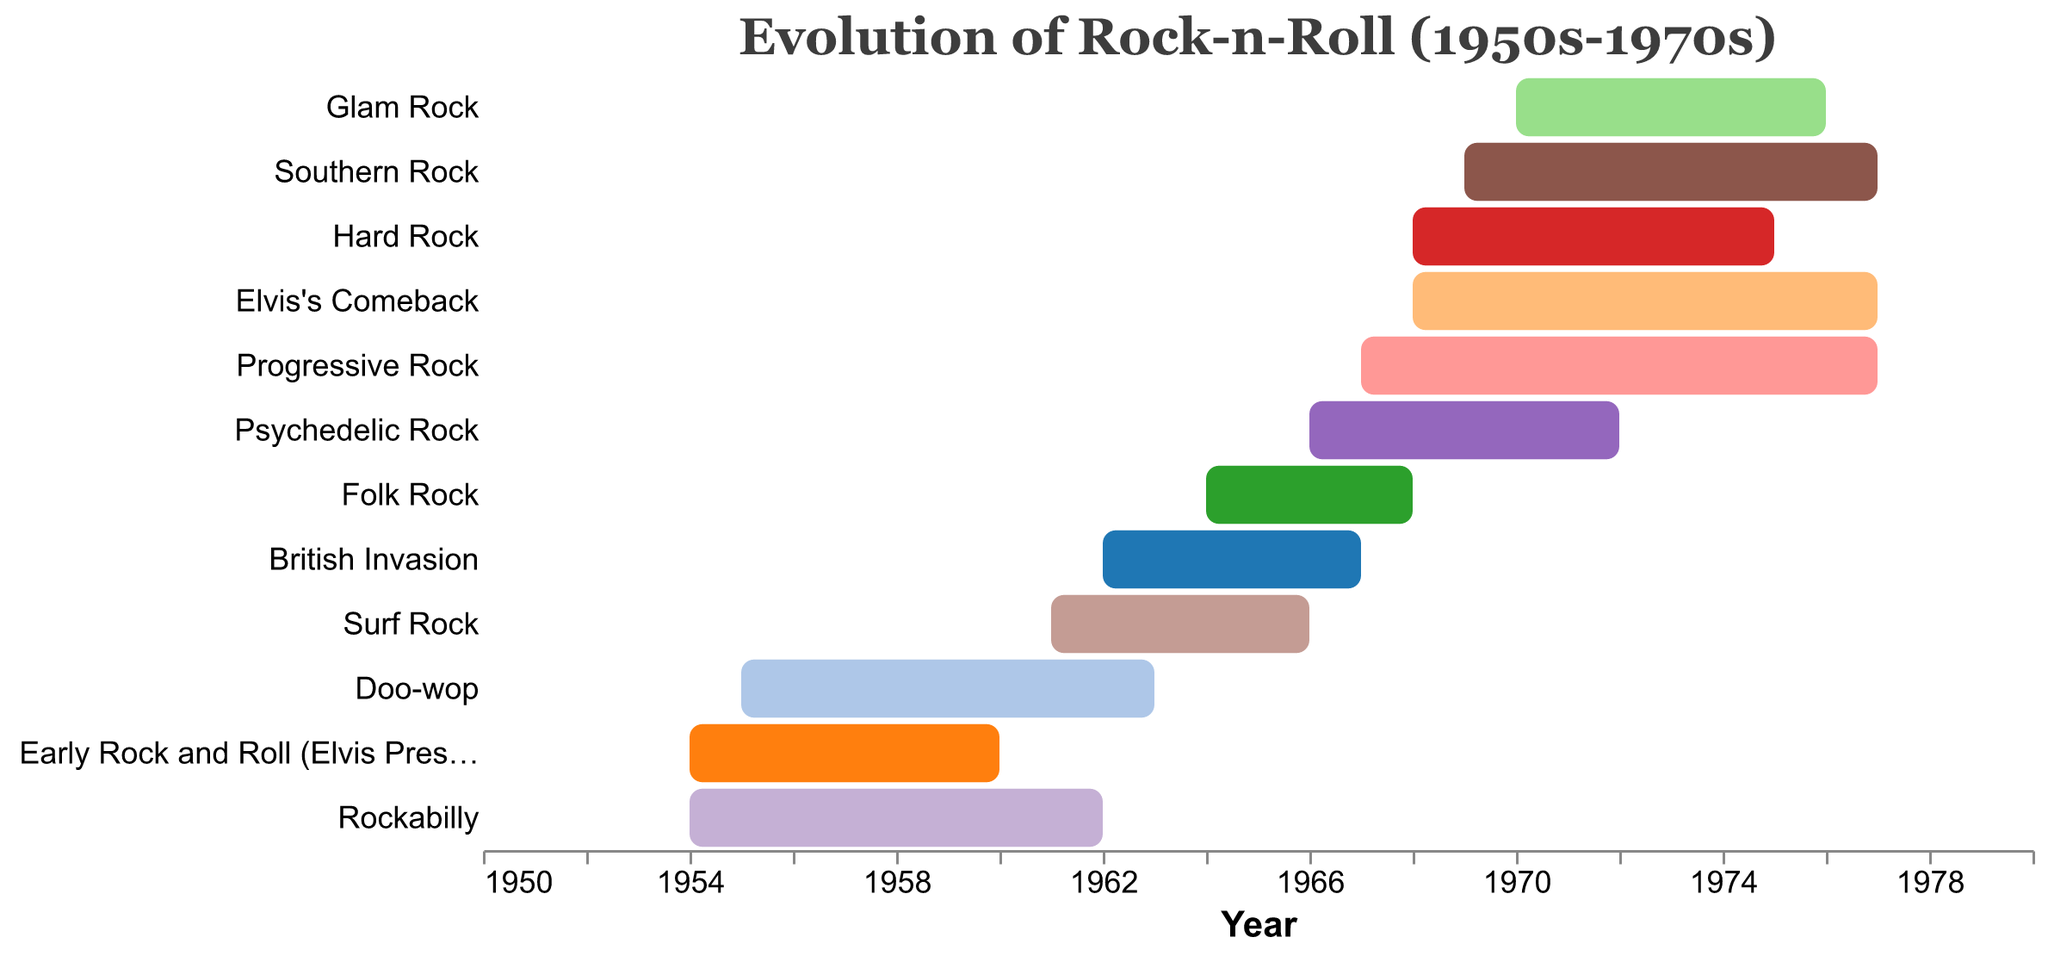What is the title of the chart? The title is displayed at the top of the chart and usually provides a summary or main subject of the visualization. Here, the title is "Evolution of Rock-n-Roll (1950s-1970s)."
Answer: Evolution of Rock-n-Roll (1950s-1970s) Which subgenre has both the earliest start and earliest end year? To answer this, locate the one with the earliest timeline in the Gantt Chart. "Rockabilly" starts in 1954 and ends in 1962, which is the earliest compared to the others.
Answer: Rockabilly How many subgenres extend into the 1970s? Count the number of bars that persist past the year 1970. There are six: Psychedelic Rock, Hard Rock, Progressive Rock, Glam Rock, Southern Rock, and Elvis's Comeback.
Answer: Six Which subgenre has the longest duration, and how many years does it span? Calculate the duration for each subgenre by subtracting the start year from the end year. Progressive Rock spans from 1967 to 1977, which is 10 years.
Answer: Progressive Rock, 10 years Is there any overlap between "Folk Rock" and "British Invasion"? Check the timelines for both 'Folk Rock' and 'British Invasion.' Folk Rock (1964-1968) overlaps with British Invasion (1962-1967).
Answer: Yes During Elvis's Comeback period, which other subgenres were also active? Identify which bars overlap with the Elvis's Comeback period (1968-1977). They are Psychedelic Rock, Hard Rock, Progressive Rock, Glam Rock, and Southern Rock.
Answer: Psychedelic Rock, Hard Rock, Progressive Rock, Glam Rock, Southern Rock Which subgenre ended first, and in what year did it end? Check the end year of each subgenre to find out which one concluded first. "Early Rock and Roll (Elvis Presley Era)" ends in 1960.
Answer: Early Rock and Roll (Elvis Presley Era), 1960 Calculate the average duration (in years) of all subgenres in the chart. Sum the duration of all subgenres and divide by the total number. The individual durations are: 6, 8, 8, 5, 5, 4, 6, 7, 10, 6, 8, 9. The total sum is 82, and dividing by 12 gives approximately 6.83 years.
Answer: 6.83 years Which subgenres start in the same year as or after Elvis's Comeback and are active until 1975 or beyond? Identify subgenres that began in or after 1968 and continued until at least 1975. "Hard Rock," "Progressive Rock," "Glam Rock," and "Southern Rock" meet this criterion.
Answer: Hard Rock, Progressive Rock, Glam Rock, Southern Rock 